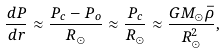Convert formula to latex. <formula><loc_0><loc_0><loc_500><loc_500>\frac { d P } { d r } \approx \frac { P _ { c } - P _ { o } } { R _ { \odot } } \approx \frac { P _ { c } } { R _ { \odot } } \approx \frac { G M _ { \odot } \bar { \rho } } { R _ { \odot } ^ { 2 } } ,</formula> 